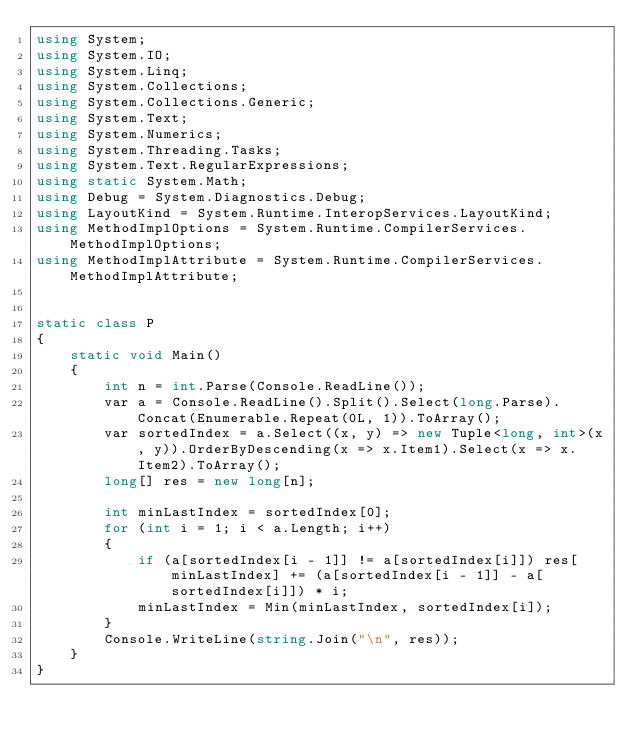Convert code to text. <code><loc_0><loc_0><loc_500><loc_500><_C#_>using System;
using System.IO;
using System.Linq;
using System.Collections;
using System.Collections.Generic;
using System.Text;
using System.Numerics;
using System.Threading.Tasks;
using System.Text.RegularExpressions;
using static System.Math;
using Debug = System.Diagnostics.Debug;
using LayoutKind = System.Runtime.InteropServices.LayoutKind;
using MethodImplOptions = System.Runtime.CompilerServices.MethodImplOptions;
using MethodImplAttribute = System.Runtime.CompilerServices.MethodImplAttribute;


static class P
{
    static void Main()
    {
        int n = int.Parse(Console.ReadLine());
        var a = Console.ReadLine().Split().Select(long.Parse).Concat(Enumerable.Repeat(0L, 1)).ToArray();
        var sortedIndex = a.Select((x, y) => new Tuple<long, int>(x, y)).OrderByDescending(x => x.Item1).Select(x => x.Item2).ToArray();
        long[] res = new long[n];

        int minLastIndex = sortedIndex[0];
        for (int i = 1; i < a.Length; i++)
        {
            if (a[sortedIndex[i - 1]] != a[sortedIndex[i]]) res[minLastIndex] += (a[sortedIndex[i - 1]] - a[sortedIndex[i]]) * i;
            minLastIndex = Min(minLastIndex, sortedIndex[i]);
        }
        Console.WriteLine(string.Join("\n", res));
    }
}
</code> 